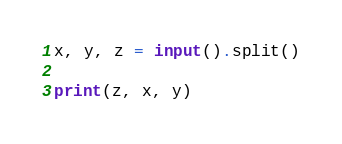Convert code to text. <code><loc_0><loc_0><loc_500><loc_500><_Python_>x, y, z = input().split()

print(z, x, y)</code> 